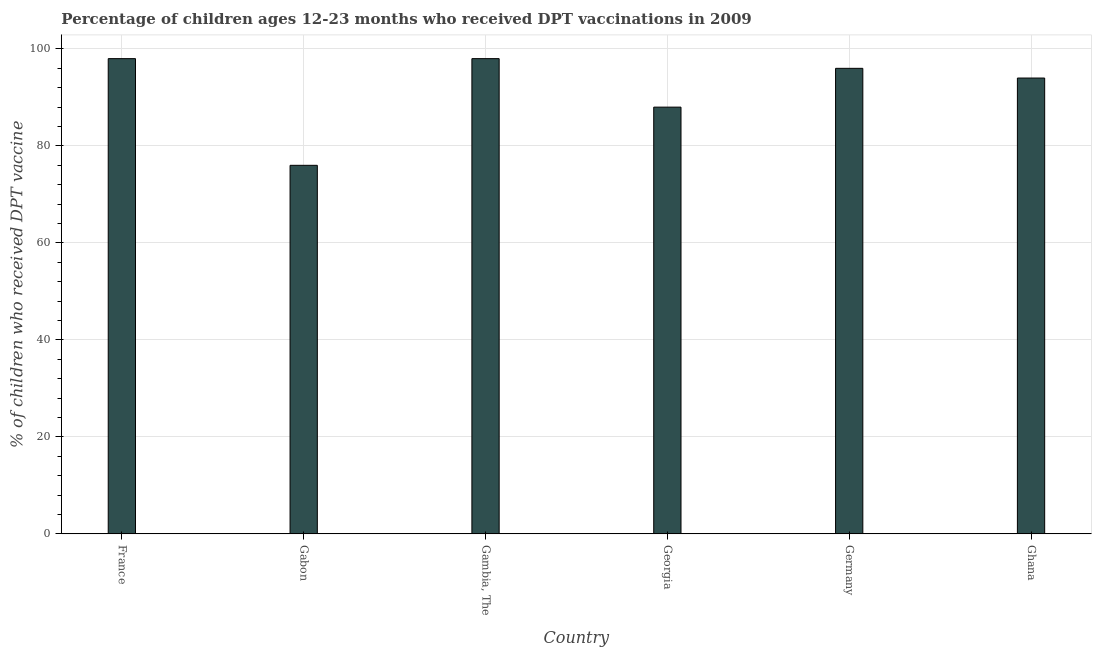Does the graph contain any zero values?
Provide a short and direct response. No. Does the graph contain grids?
Offer a terse response. Yes. What is the title of the graph?
Offer a terse response. Percentage of children ages 12-23 months who received DPT vaccinations in 2009. What is the label or title of the X-axis?
Offer a terse response. Country. What is the label or title of the Y-axis?
Ensure brevity in your answer.  % of children who received DPT vaccine. What is the percentage of children who received dpt vaccine in Ghana?
Give a very brief answer. 94. Across all countries, what is the maximum percentage of children who received dpt vaccine?
Make the answer very short. 98. Across all countries, what is the minimum percentage of children who received dpt vaccine?
Your response must be concise. 76. In which country was the percentage of children who received dpt vaccine maximum?
Give a very brief answer. France. In which country was the percentage of children who received dpt vaccine minimum?
Provide a short and direct response. Gabon. What is the sum of the percentage of children who received dpt vaccine?
Provide a short and direct response. 550. What is the average percentage of children who received dpt vaccine per country?
Ensure brevity in your answer.  91.67. What is the median percentage of children who received dpt vaccine?
Provide a succinct answer. 95. In how many countries, is the percentage of children who received dpt vaccine greater than 8 %?
Give a very brief answer. 6. What is the ratio of the percentage of children who received dpt vaccine in Gambia, The to that in Germany?
Your answer should be compact. 1.02. Is the difference between the percentage of children who received dpt vaccine in Gabon and Gambia, The greater than the difference between any two countries?
Keep it short and to the point. Yes. What is the difference between the highest and the lowest percentage of children who received dpt vaccine?
Make the answer very short. 22. How many bars are there?
Offer a terse response. 6. Are all the bars in the graph horizontal?
Your answer should be compact. No. How many countries are there in the graph?
Your answer should be very brief. 6. What is the % of children who received DPT vaccine in Gambia, The?
Ensure brevity in your answer.  98. What is the % of children who received DPT vaccine in Germany?
Keep it short and to the point. 96. What is the % of children who received DPT vaccine of Ghana?
Your response must be concise. 94. What is the difference between the % of children who received DPT vaccine in Gabon and Gambia, The?
Keep it short and to the point. -22. What is the difference between the % of children who received DPT vaccine in Gabon and Germany?
Your response must be concise. -20. What is the difference between the % of children who received DPT vaccine in Gabon and Ghana?
Your answer should be very brief. -18. What is the difference between the % of children who received DPT vaccine in Gambia, The and Georgia?
Your answer should be compact. 10. What is the difference between the % of children who received DPT vaccine in Gambia, The and Germany?
Provide a succinct answer. 2. What is the difference between the % of children who received DPT vaccine in Georgia and Germany?
Your answer should be compact. -8. What is the difference between the % of children who received DPT vaccine in Georgia and Ghana?
Offer a terse response. -6. What is the ratio of the % of children who received DPT vaccine in France to that in Gabon?
Offer a very short reply. 1.29. What is the ratio of the % of children who received DPT vaccine in France to that in Gambia, The?
Your answer should be compact. 1. What is the ratio of the % of children who received DPT vaccine in France to that in Georgia?
Give a very brief answer. 1.11. What is the ratio of the % of children who received DPT vaccine in France to that in Germany?
Provide a succinct answer. 1.02. What is the ratio of the % of children who received DPT vaccine in France to that in Ghana?
Make the answer very short. 1.04. What is the ratio of the % of children who received DPT vaccine in Gabon to that in Gambia, The?
Your answer should be compact. 0.78. What is the ratio of the % of children who received DPT vaccine in Gabon to that in Georgia?
Your answer should be compact. 0.86. What is the ratio of the % of children who received DPT vaccine in Gabon to that in Germany?
Make the answer very short. 0.79. What is the ratio of the % of children who received DPT vaccine in Gabon to that in Ghana?
Provide a succinct answer. 0.81. What is the ratio of the % of children who received DPT vaccine in Gambia, The to that in Georgia?
Ensure brevity in your answer.  1.11. What is the ratio of the % of children who received DPT vaccine in Gambia, The to that in Ghana?
Your answer should be compact. 1.04. What is the ratio of the % of children who received DPT vaccine in Georgia to that in Germany?
Your answer should be compact. 0.92. What is the ratio of the % of children who received DPT vaccine in Georgia to that in Ghana?
Make the answer very short. 0.94. 